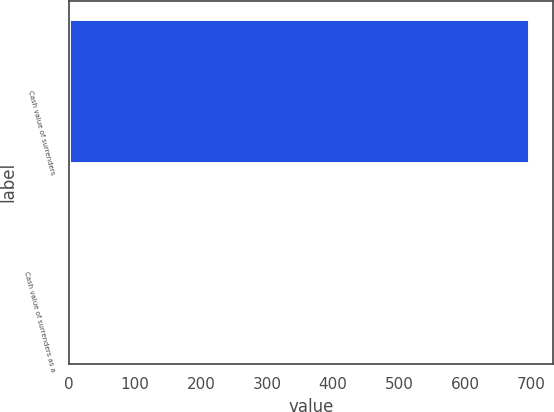<chart> <loc_0><loc_0><loc_500><loc_500><bar_chart><fcel>Cash value of surrenders<fcel>Cash value of surrenders as a<nl><fcel>698<fcel>3.5<nl></chart> 